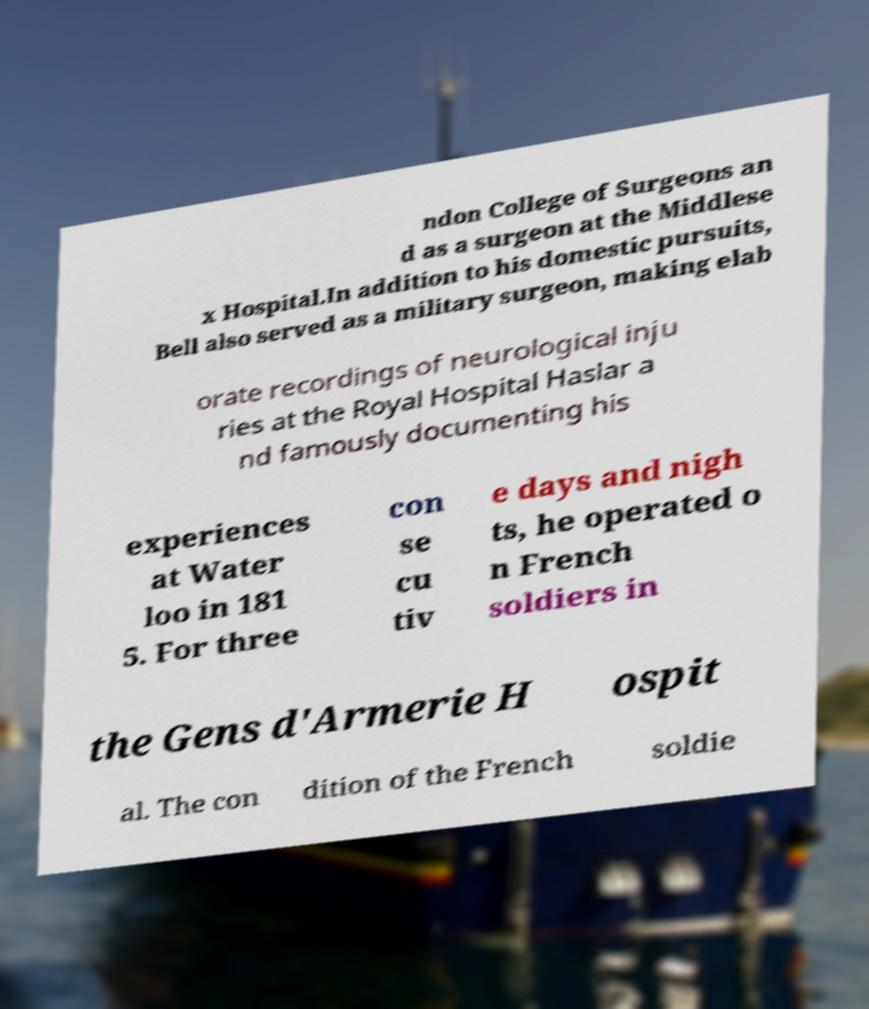Can you accurately transcribe the text from the provided image for me? ndon College of Surgeons an d as a surgeon at the Middlese x Hospital.In addition to his domestic pursuits, Bell also served as a military surgeon, making elab orate recordings of neurological inju ries at the Royal Hospital Haslar a nd famously documenting his experiences at Water loo in 181 5. For three con se cu tiv e days and nigh ts, he operated o n French soldiers in the Gens d'Armerie H ospit al. The con dition of the French soldie 